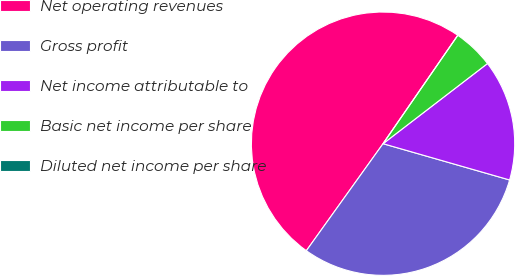<chart> <loc_0><loc_0><loc_500><loc_500><pie_chart><fcel>Net operating revenues<fcel>Gross profit<fcel>Net income attributable to<fcel>Basic net income per share<fcel>Diluted net income per share<nl><fcel>49.71%<fcel>30.45%<fcel>14.86%<fcel>4.97%<fcel>0.0%<nl></chart> 